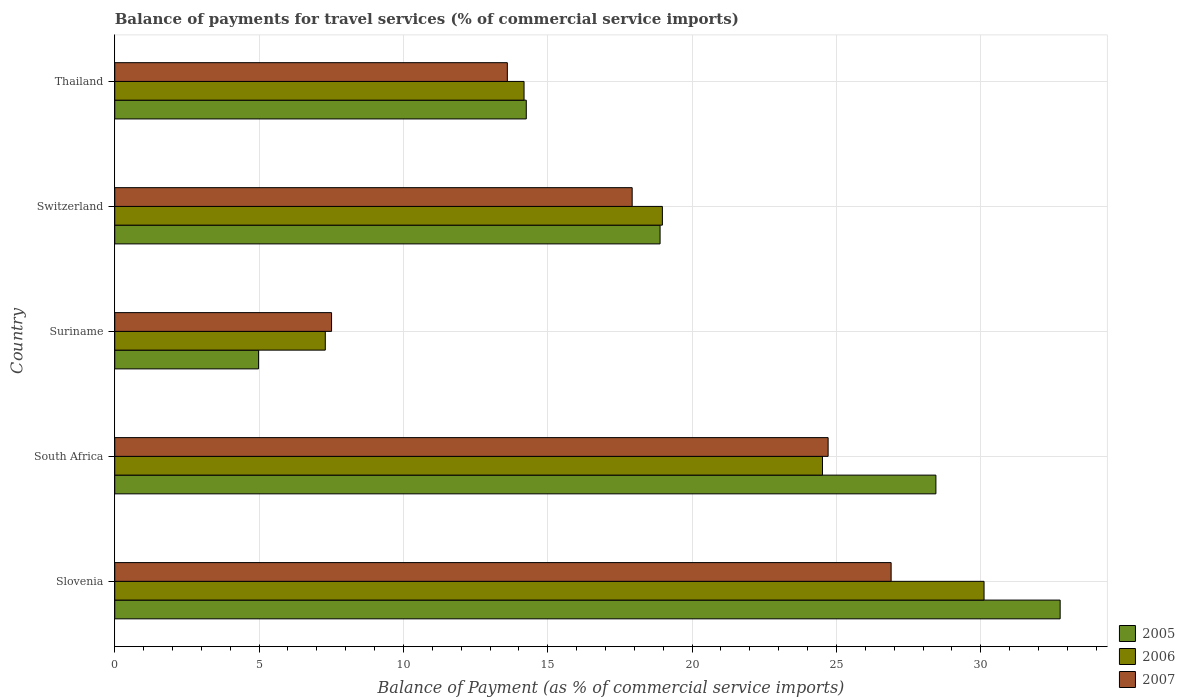How many groups of bars are there?
Provide a short and direct response. 5. Are the number of bars on each tick of the Y-axis equal?
Offer a very short reply. Yes. What is the label of the 4th group of bars from the top?
Offer a terse response. South Africa. In how many cases, is the number of bars for a given country not equal to the number of legend labels?
Your response must be concise. 0. What is the balance of payments for travel services in 2007 in Suriname?
Your answer should be compact. 7.51. Across all countries, what is the maximum balance of payments for travel services in 2007?
Give a very brief answer. 26.9. Across all countries, what is the minimum balance of payments for travel services in 2007?
Offer a very short reply. 7.51. In which country was the balance of payments for travel services in 2005 maximum?
Offer a very short reply. Slovenia. In which country was the balance of payments for travel services in 2006 minimum?
Give a very brief answer. Suriname. What is the total balance of payments for travel services in 2006 in the graph?
Provide a succinct answer. 95.08. What is the difference between the balance of payments for travel services in 2007 in Slovenia and that in Thailand?
Keep it short and to the point. 13.3. What is the difference between the balance of payments for travel services in 2006 in Slovenia and the balance of payments for travel services in 2005 in Switzerland?
Keep it short and to the point. 11.22. What is the average balance of payments for travel services in 2006 per country?
Your response must be concise. 19.02. What is the difference between the balance of payments for travel services in 2006 and balance of payments for travel services in 2007 in Switzerland?
Offer a terse response. 1.05. In how many countries, is the balance of payments for travel services in 2006 greater than 7 %?
Your answer should be very brief. 5. What is the ratio of the balance of payments for travel services in 2005 in Slovenia to that in South Africa?
Provide a succinct answer. 1.15. Is the difference between the balance of payments for travel services in 2006 in South Africa and Thailand greater than the difference between the balance of payments for travel services in 2007 in South Africa and Thailand?
Your answer should be compact. No. What is the difference between the highest and the second highest balance of payments for travel services in 2007?
Provide a short and direct response. 2.18. What is the difference between the highest and the lowest balance of payments for travel services in 2007?
Ensure brevity in your answer.  19.38. What does the 1st bar from the top in Slovenia represents?
Keep it short and to the point. 2007. What does the 3rd bar from the bottom in Suriname represents?
Keep it short and to the point. 2007. What is the difference between two consecutive major ticks on the X-axis?
Provide a succinct answer. 5. Does the graph contain any zero values?
Make the answer very short. No. Does the graph contain grids?
Your response must be concise. Yes. What is the title of the graph?
Offer a terse response. Balance of payments for travel services (% of commercial service imports). Does "2009" appear as one of the legend labels in the graph?
Offer a very short reply. No. What is the label or title of the X-axis?
Offer a very short reply. Balance of Payment (as % of commercial service imports). What is the label or title of the Y-axis?
Offer a very short reply. Country. What is the Balance of Payment (as % of commercial service imports) in 2005 in Slovenia?
Offer a very short reply. 32.75. What is the Balance of Payment (as % of commercial service imports) in 2006 in Slovenia?
Your answer should be very brief. 30.11. What is the Balance of Payment (as % of commercial service imports) of 2007 in Slovenia?
Your answer should be compact. 26.9. What is the Balance of Payment (as % of commercial service imports) in 2005 in South Africa?
Provide a short and direct response. 28.45. What is the Balance of Payment (as % of commercial service imports) in 2006 in South Africa?
Provide a short and direct response. 24.52. What is the Balance of Payment (as % of commercial service imports) in 2007 in South Africa?
Provide a succinct answer. 24.71. What is the Balance of Payment (as % of commercial service imports) in 2005 in Suriname?
Your answer should be compact. 4.98. What is the Balance of Payment (as % of commercial service imports) in 2006 in Suriname?
Keep it short and to the point. 7.29. What is the Balance of Payment (as % of commercial service imports) in 2007 in Suriname?
Provide a succinct answer. 7.51. What is the Balance of Payment (as % of commercial service imports) of 2005 in Switzerland?
Keep it short and to the point. 18.89. What is the Balance of Payment (as % of commercial service imports) in 2006 in Switzerland?
Offer a very short reply. 18.97. What is the Balance of Payment (as % of commercial service imports) of 2007 in Switzerland?
Your answer should be very brief. 17.92. What is the Balance of Payment (as % of commercial service imports) of 2005 in Thailand?
Provide a succinct answer. 14.26. What is the Balance of Payment (as % of commercial service imports) in 2006 in Thailand?
Provide a succinct answer. 14.18. What is the Balance of Payment (as % of commercial service imports) of 2007 in Thailand?
Give a very brief answer. 13.6. Across all countries, what is the maximum Balance of Payment (as % of commercial service imports) in 2005?
Your response must be concise. 32.75. Across all countries, what is the maximum Balance of Payment (as % of commercial service imports) in 2006?
Make the answer very short. 30.11. Across all countries, what is the maximum Balance of Payment (as % of commercial service imports) of 2007?
Offer a very short reply. 26.9. Across all countries, what is the minimum Balance of Payment (as % of commercial service imports) in 2005?
Offer a terse response. 4.98. Across all countries, what is the minimum Balance of Payment (as % of commercial service imports) of 2006?
Provide a short and direct response. 7.29. Across all countries, what is the minimum Balance of Payment (as % of commercial service imports) in 2007?
Keep it short and to the point. 7.51. What is the total Balance of Payment (as % of commercial service imports) of 2005 in the graph?
Keep it short and to the point. 99.33. What is the total Balance of Payment (as % of commercial service imports) of 2006 in the graph?
Offer a terse response. 95.08. What is the total Balance of Payment (as % of commercial service imports) of 2007 in the graph?
Offer a terse response. 90.65. What is the difference between the Balance of Payment (as % of commercial service imports) of 2005 in Slovenia and that in South Africa?
Ensure brevity in your answer.  4.3. What is the difference between the Balance of Payment (as % of commercial service imports) of 2006 in Slovenia and that in South Africa?
Keep it short and to the point. 5.6. What is the difference between the Balance of Payment (as % of commercial service imports) in 2007 in Slovenia and that in South Africa?
Keep it short and to the point. 2.18. What is the difference between the Balance of Payment (as % of commercial service imports) of 2005 in Slovenia and that in Suriname?
Offer a very short reply. 27.77. What is the difference between the Balance of Payment (as % of commercial service imports) of 2006 in Slovenia and that in Suriname?
Provide a succinct answer. 22.82. What is the difference between the Balance of Payment (as % of commercial service imports) in 2007 in Slovenia and that in Suriname?
Ensure brevity in your answer.  19.38. What is the difference between the Balance of Payment (as % of commercial service imports) in 2005 in Slovenia and that in Switzerland?
Ensure brevity in your answer.  13.86. What is the difference between the Balance of Payment (as % of commercial service imports) in 2006 in Slovenia and that in Switzerland?
Your answer should be compact. 11.14. What is the difference between the Balance of Payment (as % of commercial service imports) in 2007 in Slovenia and that in Switzerland?
Ensure brevity in your answer.  8.97. What is the difference between the Balance of Payment (as % of commercial service imports) in 2005 in Slovenia and that in Thailand?
Your answer should be very brief. 18.5. What is the difference between the Balance of Payment (as % of commercial service imports) in 2006 in Slovenia and that in Thailand?
Ensure brevity in your answer.  15.94. What is the difference between the Balance of Payment (as % of commercial service imports) of 2007 in Slovenia and that in Thailand?
Keep it short and to the point. 13.3. What is the difference between the Balance of Payment (as % of commercial service imports) of 2005 in South Africa and that in Suriname?
Your answer should be very brief. 23.46. What is the difference between the Balance of Payment (as % of commercial service imports) of 2006 in South Africa and that in Suriname?
Your answer should be very brief. 17.22. What is the difference between the Balance of Payment (as % of commercial service imports) in 2007 in South Africa and that in Suriname?
Provide a short and direct response. 17.2. What is the difference between the Balance of Payment (as % of commercial service imports) in 2005 in South Africa and that in Switzerland?
Make the answer very short. 9.56. What is the difference between the Balance of Payment (as % of commercial service imports) of 2006 in South Africa and that in Switzerland?
Offer a very short reply. 5.55. What is the difference between the Balance of Payment (as % of commercial service imports) of 2007 in South Africa and that in Switzerland?
Ensure brevity in your answer.  6.79. What is the difference between the Balance of Payment (as % of commercial service imports) in 2005 in South Africa and that in Thailand?
Keep it short and to the point. 14.19. What is the difference between the Balance of Payment (as % of commercial service imports) of 2006 in South Africa and that in Thailand?
Your response must be concise. 10.34. What is the difference between the Balance of Payment (as % of commercial service imports) in 2007 in South Africa and that in Thailand?
Offer a terse response. 11.11. What is the difference between the Balance of Payment (as % of commercial service imports) in 2005 in Suriname and that in Switzerland?
Provide a short and direct response. -13.91. What is the difference between the Balance of Payment (as % of commercial service imports) in 2006 in Suriname and that in Switzerland?
Keep it short and to the point. -11.68. What is the difference between the Balance of Payment (as % of commercial service imports) in 2007 in Suriname and that in Switzerland?
Make the answer very short. -10.41. What is the difference between the Balance of Payment (as % of commercial service imports) of 2005 in Suriname and that in Thailand?
Offer a very short reply. -9.27. What is the difference between the Balance of Payment (as % of commercial service imports) of 2006 in Suriname and that in Thailand?
Ensure brevity in your answer.  -6.89. What is the difference between the Balance of Payment (as % of commercial service imports) of 2007 in Suriname and that in Thailand?
Offer a very short reply. -6.09. What is the difference between the Balance of Payment (as % of commercial service imports) in 2005 in Switzerland and that in Thailand?
Keep it short and to the point. 4.64. What is the difference between the Balance of Payment (as % of commercial service imports) in 2006 in Switzerland and that in Thailand?
Your response must be concise. 4.79. What is the difference between the Balance of Payment (as % of commercial service imports) of 2007 in Switzerland and that in Thailand?
Provide a succinct answer. 4.32. What is the difference between the Balance of Payment (as % of commercial service imports) of 2005 in Slovenia and the Balance of Payment (as % of commercial service imports) of 2006 in South Africa?
Make the answer very short. 8.23. What is the difference between the Balance of Payment (as % of commercial service imports) in 2005 in Slovenia and the Balance of Payment (as % of commercial service imports) in 2007 in South Africa?
Your response must be concise. 8.04. What is the difference between the Balance of Payment (as % of commercial service imports) in 2006 in Slovenia and the Balance of Payment (as % of commercial service imports) in 2007 in South Africa?
Your response must be concise. 5.4. What is the difference between the Balance of Payment (as % of commercial service imports) in 2005 in Slovenia and the Balance of Payment (as % of commercial service imports) in 2006 in Suriname?
Ensure brevity in your answer.  25.46. What is the difference between the Balance of Payment (as % of commercial service imports) of 2005 in Slovenia and the Balance of Payment (as % of commercial service imports) of 2007 in Suriname?
Your answer should be very brief. 25.24. What is the difference between the Balance of Payment (as % of commercial service imports) in 2006 in Slovenia and the Balance of Payment (as % of commercial service imports) in 2007 in Suriname?
Your answer should be compact. 22.6. What is the difference between the Balance of Payment (as % of commercial service imports) of 2005 in Slovenia and the Balance of Payment (as % of commercial service imports) of 2006 in Switzerland?
Ensure brevity in your answer.  13.78. What is the difference between the Balance of Payment (as % of commercial service imports) in 2005 in Slovenia and the Balance of Payment (as % of commercial service imports) in 2007 in Switzerland?
Offer a terse response. 14.83. What is the difference between the Balance of Payment (as % of commercial service imports) in 2006 in Slovenia and the Balance of Payment (as % of commercial service imports) in 2007 in Switzerland?
Your answer should be very brief. 12.19. What is the difference between the Balance of Payment (as % of commercial service imports) in 2005 in Slovenia and the Balance of Payment (as % of commercial service imports) in 2006 in Thailand?
Give a very brief answer. 18.57. What is the difference between the Balance of Payment (as % of commercial service imports) of 2005 in Slovenia and the Balance of Payment (as % of commercial service imports) of 2007 in Thailand?
Your response must be concise. 19.15. What is the difference between the Balance of Payment (as % of commercial service imports) of 2006 in Slovenia and the Balance of Payment (as % of commercial service imports) of 2007 in Thailand?
Keep it short and to the point. 16.51. What is the difference between the Balance of Payment (as % of commercial service imports) of 2005 in South Africa and the Balance of Payment (as % of commercial service imports) of 2006 in Suriname?
Offer a terse response. 21.15. What is the difference between the Balance of Payment (as % of commercial service imports) in 2005 in South Africa and the Balance of Payment (as % of commercial service imports) in 2007 in Suriname?
Provide a short and direct response. 20.94. What is the difference between the Balance of Payment (as % of commercial service imports) in 2006 in South Africa and the Balance of Payment (as % of commercial service imports) in 2007 in Suriname?
Your answer should be compact. 17.01. What is the difference between the Balance of Payment (as % of commercial service imports) of 2005 in South Africa and the Balance of Payment (as % of commercial service imports) of 2006 in Switzerland?
Your answer should be very brief. 9.48. What is the difference between the Balance of Payment (as % of commercial service imports) of 2005 in South Africa and the Balance of Payment (as % of commercial service imports) of 2007 in Switzerland?
Your answer should be very brief. 10.52. What is the difference between the Balance of Payment (as % of commercial service imports) of 2006 in South Africa and the Balance of Payment (as % of commercial service imports) of 2007 in Switzerland?
Provide a short and direct response. 6.59. What is the difference between the Balance of Payment (as % of commercial service imports) in 2005 in South Africa and the Balance of Payment (as % of commercial service imports) in 2006 in Thailand?
Your answer should be compact. 14.27. What is the difference between the Balance of Payment (as % of commercial service imports) in 2005 in South Africa and the Balance of Payment (as % of commercial service imports) in 2007 in Thailand?
Your response must be concise. 14.85. What is the difference between the Balance of Payment (as % of commercial service imports) in 2006 in South Africa and the Balance of Payment (as % of commercial service imports) in 2007 in Thailand?
Your answer should be very brief. 10.92. What is the difference between the Balance of Payment (as % of commercial service imports) in 2005 in Suriname and the Balance of Payment (as % of commercial service imports) in 2006 in Switzerland?
Provide a succinct answer. -13.99. What is the difference between the Balance of Payment (as % of commercial service imports) in 2005 in Suriname and the Balance of Payment (as % of commercial service imports) in 2007 in Switzerland?
Make the answer very short. -12.94. What is the difference between the Balance of Payment (as % of commercial service imports) of 2006 in Suriname and the Balance of Payment (as % of commercial service imports) of 2007 in Switzerland?
Provide a succinct answer. -10.63. What is the difference between the Balance of Payment (as % of commercial service imports) of 2005 in Suriname and the Balance of Payment (as % of commercial service imports) of 2006 in Thailand?
Make the answer very short. -9.2. What is the difference between the Balance of Payment (as % of commercial service imports) in 2005 in Suriname and the Balance of Payment (as % of commercial service imports) in 2007 in Thailand?
Provide a short and direct response. -8.62. What is the difference between the Balance of Payment (as % of commercial service imports) in 2006 in Suriname and the Balance of Payment (as % of commercial service imports) in 2007 in Thailand?
Your answer should be very brief. -6.31. What is the difference between the Balance of Payment (as % of commercial service imports) in 2005 in Switzerland and the Balance of Payment (as % of commercial service imports) in 2006 in Thailand?
Provide a short and direct response. 4.71. What is the difference between the Balance of Payment (as % of commercial service imports) in 2005 in Switzerland and the Balance of Payment (as % of commercial service imports) in 2007 in Thailand?
Your response must be concise. 5.29. What is the difference between the Balance of Payment (as % of commercial service imports) of 2006 in Switzerland and the Balance of Payment (as % of commercial service imports) of 2007 in Thailand?
Make the answer very short. 5.37. What is the average Balance of Payment (as % of commercial service imports) in 2005 per country?
Provide a succinct answer. 19.87. What is the average Balance of Payment (as % of commercial service imports) in 2006 per country?
Offer a terse response. 19.02. What is the average Balance of Payment (as % of commercial service imports) of 2007 per country?
Offer a terse response. 18.13. What is the difference between the Balance of Payment (as % of commercial service imports) in 2005 and Balance of Payment (as % of commercial service imports) in 2006 in Slovenia?
Provide a succinct answer. 2.64. What is the difference between the Balance of Payment (as % of commercial service imports) of 2005 and Balance of Payment (as % of commercial service imports) of 2007 in Slovenia?
Ensure brevity in your answer.  5.86. What is the difference between the Balance of Payment (as % of commercial service imports) in 2006 and Balance of Payment (as % of commercial service imports) in 2007 in Slovenia?
Make the answer very short. 3.22. What is the difference between the Balance of Payment (as % of commercial service imports) of 2005 and Balance of Payment (as % of commercial service imports) of 2006 in South Africa?
Ensure brevity in your answer.  3.93. What is the difference between the Balance of Payment (as % of commercial service imports) in 2005 and Balance of Payment (as % of commercial service imports) in 2007 in South Africa?
Ensure brevity in your answer.  3.73. What is the difference between the Balance of Payment (as % of commercial service imports) in 2006 and Balance of Payment (as % of commercial service imports) in 2007 in South Africa?
Make the answer very short. -0.2. What is the difference between the Balance of Payment (as % of commercial service imports) of 2005 and Balance of Payment (as % of commercial service imports) of 2006 in Suriname?
Offer a terse response. -2.31. What is the difference between the Balance of Payment (as % of commercial service imports) in 2005 and Balance of Payment (as % of commercial service imports) in 2007 in Suriname?
Your response must be concise. -2.53. What is the difference between the Balance of Payment (as % of commercial service imports) of 2006 and Balance of Payment (as % of commercial service imports) of 2007 in Suriname?
Offer a very short reply. -0.22. What is the difference between the Balance of Payment (as % of commercial service imports) in 2005 and Balance of Payment (as % of commercial service imports) in 2006 in Switzerland?
Make the answer very short. -0.08. What is the difference between the Balance of Payment (as % of commercial service imports) of 2005 and Balance of Payment (as % of commercial service imports) of 2007 in Switzerland?
Offer a very short reply. 0.97. What is the difference between the Balance of Payment (as % of commercial service imports) in 2006 and Balance of Payment (as % of commercial service imports) in 2007 in Switzerland?
Your answer should be very brief. 1.05. What is the difference between the Balance of Payment (as % of commercial service imports) of 2005 and Balance of Payment (as % of commercial service imports) of 2006 in Thailand?
Your response must be concise. 0.08. What is the difference between the Balance of Payment (as % of commercial service imports) in 2005 and Balance of Payment (as % of commercial service imports) in 2007 in Thailand?
Keep it short and to the point. 0.66. What is the difference between the Balance of Payment (as % of commercial service imports) in 2006 and Balance of Payment (as % of commercial service imports) in 2007 in Thailand?
Keep it short and to the point. 0.58. What is the ratio of the Balance of Payment (as % of commercial service imports) in 2005 in Slovenia to that in South Africa?
Offer a terse response. 1.15. What is the ratio of the Balance of Payment (as % of commercial service imports) of 2006 in Slovenia to that in South Africa?
Make the answer very short. 1.23. What is the ratio of the Balance of Payment (as % of commercial service imports) in 2007 in Slovenia to that in South Africa?
Provide a short and direct response. 1.09. What is the ratio of the Balance of Payment (as % of commercial service imports) in 2005 in Slovenia to that in Suriname?
Your response must be concise. 6.57. What is the ratio of the Balance of Payment (as % of commercial service imports) in 2006 in Slovenia to that in Suriname?
Make the answer very short. 4.13. What is the ratio of the Balance of Payment (as % of commercial service imports) in 2007 in Slovenia to that in Suriname?
Offer a very short reply. 3.58. What is the ratio of the Balance of Payment (as % of commercial service imports) in 2005 in Slovenia to that in Switzerland?
Your answer should be compact. 1.73. What is the ratio of the Balance of Payment (as % of commercial service imports) of 2006 in Slovenia to that in Switzerland?
Provide a short and direct response. 1.59. What is the ratio of the Balance of Payment (as % of commercial service imports) of 2007 in Slovenia to that in Switzerland?
Your answer should be very brief. 1.5. What is the ratio of the Balance of Payment (as % of commercial service imports) of 2005 in Slovenia to that in Thailand?
Keep it short and to the point. 2.3. What is the ratio of the Balance of Payment (as % of commercial service imports) in 2006 in Slovenia to that in Thailand?
Make the answer very short. 2.12. What is the ratio of the Balance of Payment (as % of commercial service imports) of 2007 in Slovenia to that in Thailand?
Provide a short and direct response. 1.98. What is the ratio of the Balance of Payment (as % of commercial service imports) in 2005 in South Africa to that in Suriname?
Provide a short and direct response. 5.71. What is the ratio of the Balance of Payment (as % of commercial service imports) in 2006 in South Africa to that in Suriname?
Your response must be concise. 3.36. What is the ratio of the Balance of Payment (as % of commercial service imports) of 2007 in South Africa to that in Suriname?
Make the answer very short. 3.29. What is the ratio of the Balance of Payment (as % of commercial service imports) in 2005 in South Africa to that in Switzerland?
Keep it short and to the point. 1.51. What is the ratio of the Balance of Payment (as % of commercial service imports) of 2006 in South Africa to that in Switzerland?
Provide a succinct answer. 1.29. What is the ratio of the Balance of Payment (as % of commercial service imports) in 2007 in South Africa to that in Switzerland?
Provide a succinct answer. 1.38. What is the ratio of the Balance of Payment (as % of commercial service imports) of 2005 in South Africa to that in Thailand?
Your response must be concise. 2. What is the ratio of the Balance of Payment (as % of commercial service imports) of 2006 in South Africa to that in Thailand?
Ensure brevity in your answer.  1.73. What is the ratio of the Balance of Payment (as % of commercial service imports) of 2007 in South Africa to that in Thailand?
Keep it short and to the point. 1.82. What is the ratio of the Balance of Payment (as % of commercial service imports) of 2005 in Suriname to that in Switzerland?
Give a very brief answer. 0.26. What is the ratio of the Balance of Payment (as % of commercial service imports) in 2006 in Suriname to that in Switzerland?
Keep it short and to the point. 0.38. What is the ratio of the Balance of Payment (as % of commercial service imports) in 2007 in Suriname to that in Switzerland?
Your answer should be compact. 0.42. What is the ratio of the Balance of Payment (as % of commercial service imports) in 2005 in Suriname to that in Thailand?
Offer a very short reply. 0.35. What is the ratio of the Balance of Payment (as % of commercial service imports) of 2006 in Suriname to that in Thailand?
Ensure brevity in your answer.  0.51. What is the ratio of the Balance of Payment (as % of commercial service imports) of 2007 in Suriname to that in Thailand?
Your answer should be compact. 0.55. What is the ratio of the Balance of Payment (as % of commercial service imports) in 2005 in Switzerland to that in Thailand?
Your response must be concise. 1.33. What is the ratio of the Balance of Payment (as % of commercial service imports) in 2006 in Switzerland to that in Thailand?
Offer a very short reply. 1.34. What is the ratio of the Balance of Payment (as % of commercial service imports) in 2007 in Switzerland to that in Thailand?
Keep it short and to the point. 1.32. What is the difference between the highest and the second highest Balance of Payment (as % of commercial service imports) in 2005?
Make the answer very short. 4.3. What is the difference between the highest and the second highest Balance of Payment (as % of commercial service imports) in 2006?
Give a very brief answer. 5.6. What is the difference between the highest and the second highest Balance of Payment (as % of commercial service imports) in 2007?
Ensure brevity in your answer.  2.18. What is the difference between the highest and the lowest Balance of Payment (as % of commercial service imports) of 2005?
Your answer should be very brief. 27.77. What is the difference between the highest and the lowest Balance of Payment (as % of commercial service imports) in 2006?
Your answer should be compact. 22.82. What is the difference between the highest and the lowest Balance of Payment (as % of commercial service imports) in 2007?
Provide a succinct answer. 19.38. 